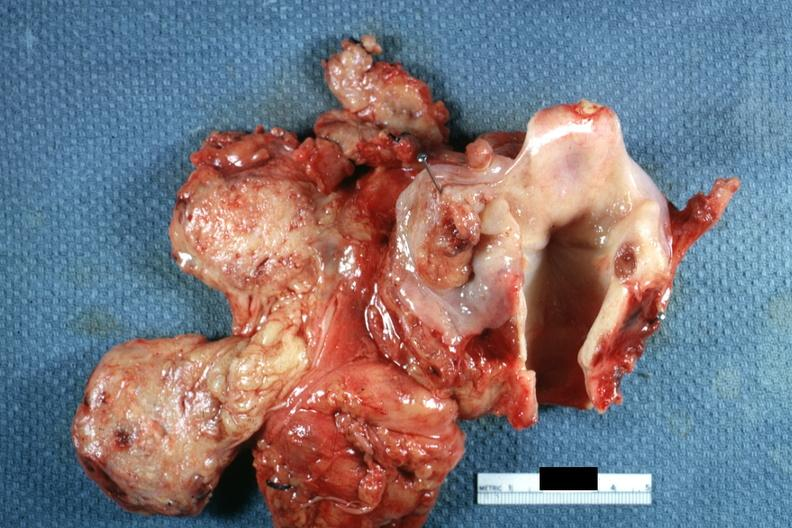s hypopharynx present?
Answer the question using a single word or phrase. Yes 